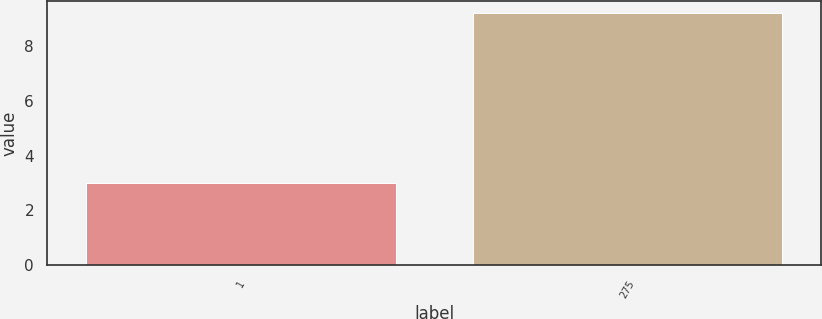Convert chart. <chart><loc_0><loc_0><loc_500><loc_500><bar_chart><fcel>1<fcel>275<nl><fcel>3<fcel>9.2<nl></chart> 